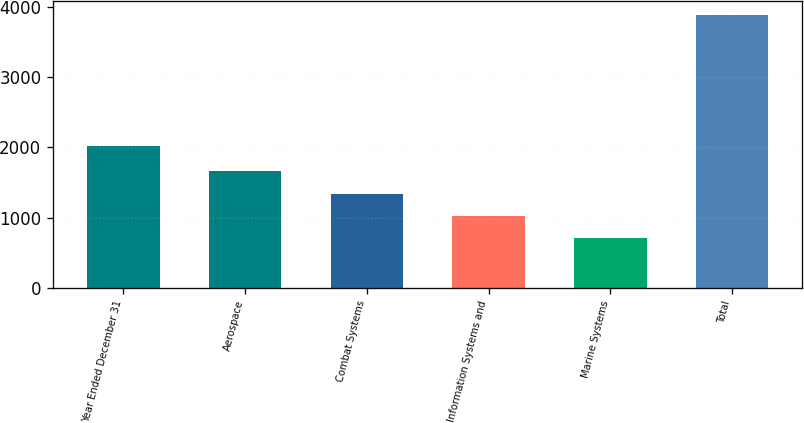Convert chart. <chart><loc_0><loc_0><loc_500><loc_500><bar_chart><fcel>Year Ended December 31<fcel>Aerospace<fcel>Combat Systems<fcel>Information Systems and<fcel>Marine Systems<fcel>Total<nl><fcel>2014<fcel>1658.8<fcel>1340.2<fcel>1021.6<fcel>703<fcel>3889<nl></chart> 